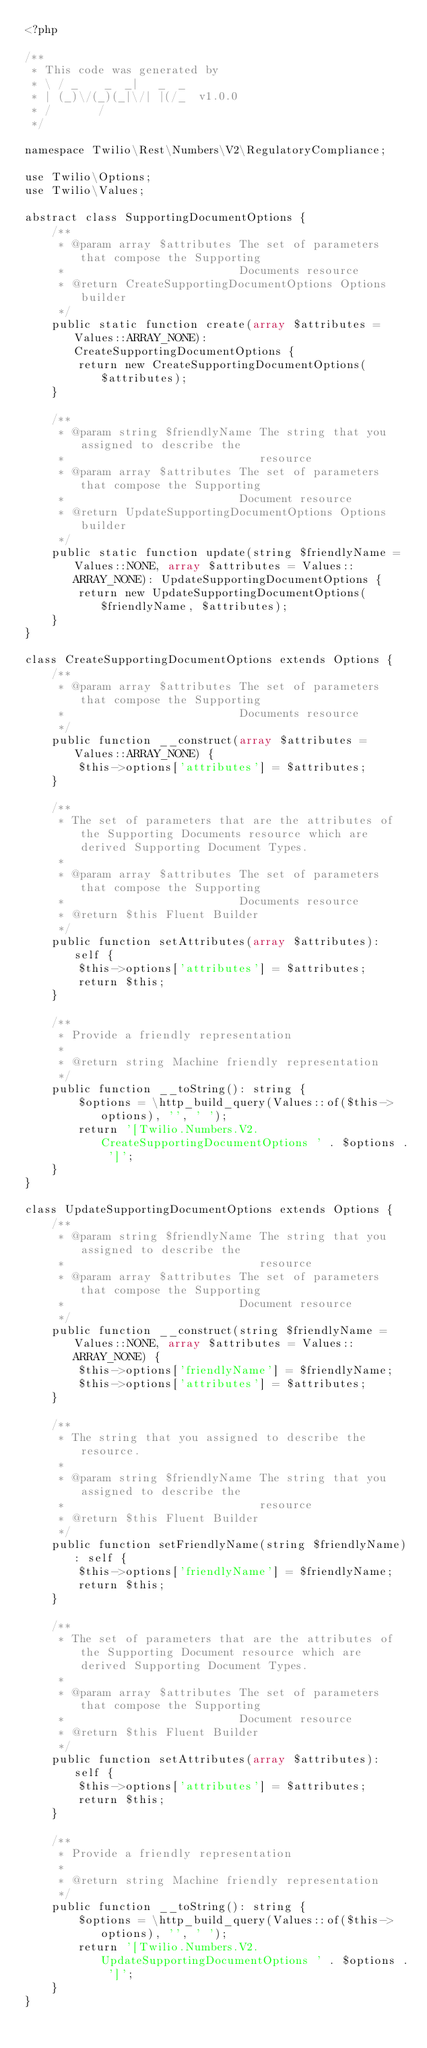Convert code to text. <code><loc_0><loc_0><loc_500><loc_500><_PHP_><?php

/**
 * This code was generated by
 * \ / _    _  _|   _  _
 * | (_)\/(_)(_|\/| |(/_  v1.0.0
 * /       /
 */

namespace Twilio\Rest\Numbers\V2\RegulatoryCompliance;

use Twilio\Options;
use Twilio\Values;

abstract class SupportingDocumentOptions {
    /**
     * @param array $attributes The set of parameters that compose the Supporting
     *                          Documents resource
     * @return CreateSupportingDocumentOptions Options builder
     */
    public static function create(array $attributes = Values::ARRAY_NONE): CreateSupportingDocumentOptions {
        return new CreateSupportingDocumentOptions($attributes);
    }

    /**
     * @param string $friendlyName The string that you assigned to describe the
     *                             resource
     * @param array $attributes The set of parameters that compose the Supporting
     *                          Document resource
     * @return UpdateSupportingDocumentOptions Options builder
     */
    public static function update(string $friendlyName = Values::NONE, array $attributes = Values::ARRAY_NONE): UpdateSupportingDocumentOptions {
        return new UpdateSupportingDocumentOptions($friendlyName, $attributes);
    }
}

class CreateSupportingDocumentOptions extends Options {
    /**
     * @param array $attributes The set of parameters that compose the Supporting
     *                          Documents resource
     */
    public function __construct(array $attributes = Values::ARRAY_NONE) {
        $this->options['attributes'] = $attributes;
    }

    /**
     * The set of parameters that are the attributes of the Supporting Documents resource which are derived Supporting Document Types.
     *
     * @param array $attributes The set of parameters that compose the Supporting
     *                          Documents resource
     * @return $this Fluent Builder
     */
    public function setAttributes(array $attributes): self {
        $this->options['attributes'] = $attributes;
        return $this;
    }

    /**
     * Provide a friendly representation
     *
     * @return string Machine friendly representation
     */
    public function __toString(): string {
        $options = \http_build_query(Values::of($this->options), '', ' ');
        return '[Twilio.Numbers.V2.CreateSupportingDocumentOptions ' . $options . ']';
    }
}

class UpdateSupportingDocumentOptions extends Options {
    /**
     * @param string $friendlyName The string that you assigned to describe the
     *                             resource
     * @param array $attributes The set of parameters that compose the Supporting
     *                          Document resource
     */
    public function __construct(string $friendlyName = Values::NONE, array $attributes = Values::ARRAY_NONE) {
        $this->options['friendlyName'] = $friendlyName;
        $this->options['attributes'] = $attributes;
    }

    /**
     * The string that you assigned to describe the resource.
     *
     * @param string $friendlyName The string that you assigned to describe the
     *                             resource
     * @return $this Fluent Builder
     */
    public function setFriendlyName(string $friendlyName): self {
        $this->options['friendlyName'] = $friendlyName;
        return $this;
    }

    /**
     * The set of parameters that are the attributes of the Supporting Document resource which are derived Supporting Document Types.
     *
     * @param array $attributes The set of parameters that compose the Supporting
     *                          Document resource
     * @return $this Fluent Builder
     */
    public function setAttributes(array $attributes): self {
        $this->options['attributes'] = $attributes;
        return $this;
    }

    /**
     * Provide a friendly representation
     *
     * @return string Machine friendly representation
     */
    public function __toString(): string {
        $options = \http_build_query(Values::of($this->options), '', ' ');
        return '[Twilio.Numbers.V2.UpdateSupportingDocumentOptions ' . $options . ']';
    }
}</code> 